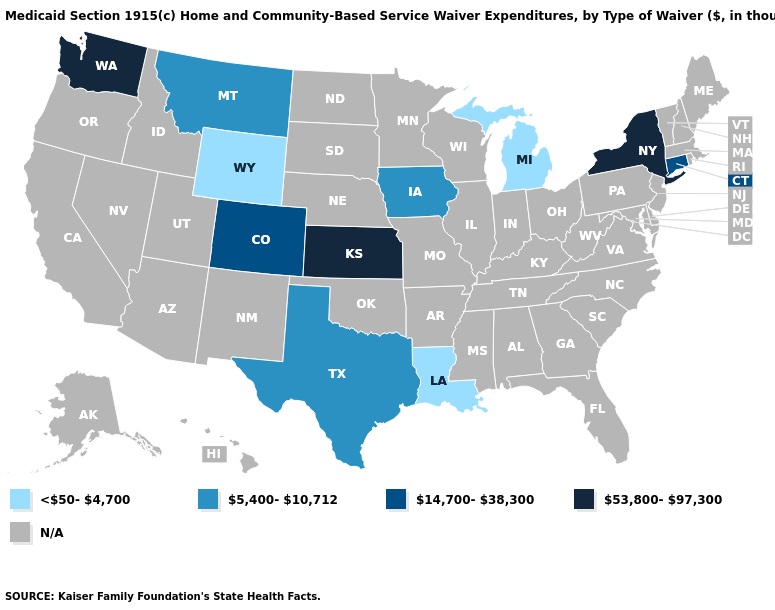What is the value of Missouri?
Short answer required. N/A. Among the states that border Massachusetts , does New York have the highest value?
Write a very short answer. Yes. Does Texas have the lowest value in the USA?
Keep it brief. No. Among the states that border Idaho , does Montana have the highest value?
Quick response, please. No. Name the states that have a value in the range 53,800-97,300?
Concise answer only. Kansas, New York, Washington. What is the value of Mississippi?
Answer briefly. N/A. Name the states that have a value in the range 14,700-38,300?
Quick response, please. Colorado, Connecticut. What is the highest value in states that border Arkansas?
Quick response, please. 5,400-10,712. Which states have the lowest value in the West?
Keep it brief. Wyoming. Does the first symbol in the legend represent the smallest category?
Give a very brief answer. Yes. Name the states that have a value in the range 5,400-10,712?
Short answer required. Iowa, Montana, Texas. What is the value of Massachusetts?
Concise answer only. N/A. What is the lowest value in the USA?
Quick response, please. <50-4,700. Among the states that border Louisiana , which have the lowest value?
Give a very brief answer. Texas. 